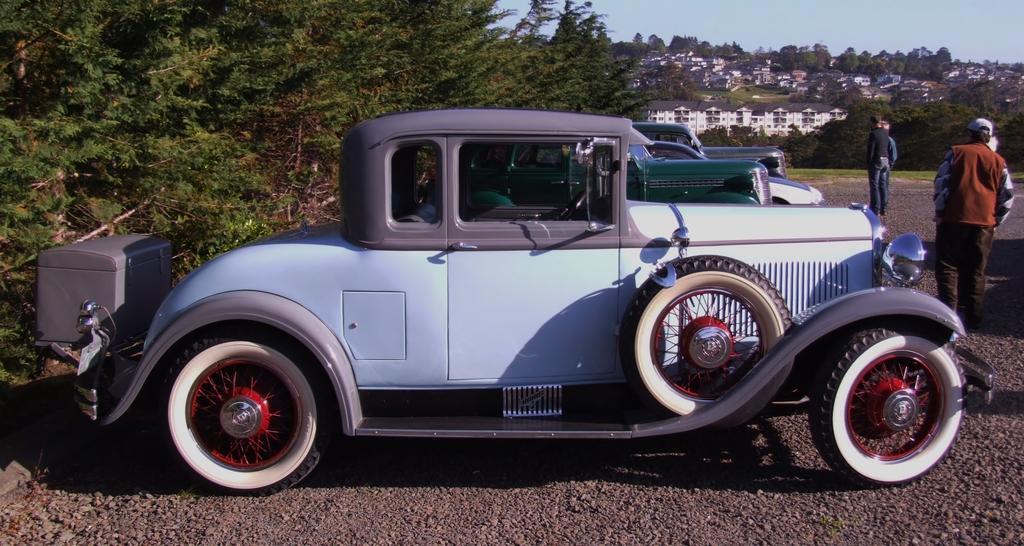Can you describe this image briefly? In this image we can see some people standing and we can also see vehicles, buildings, trees and sky. 